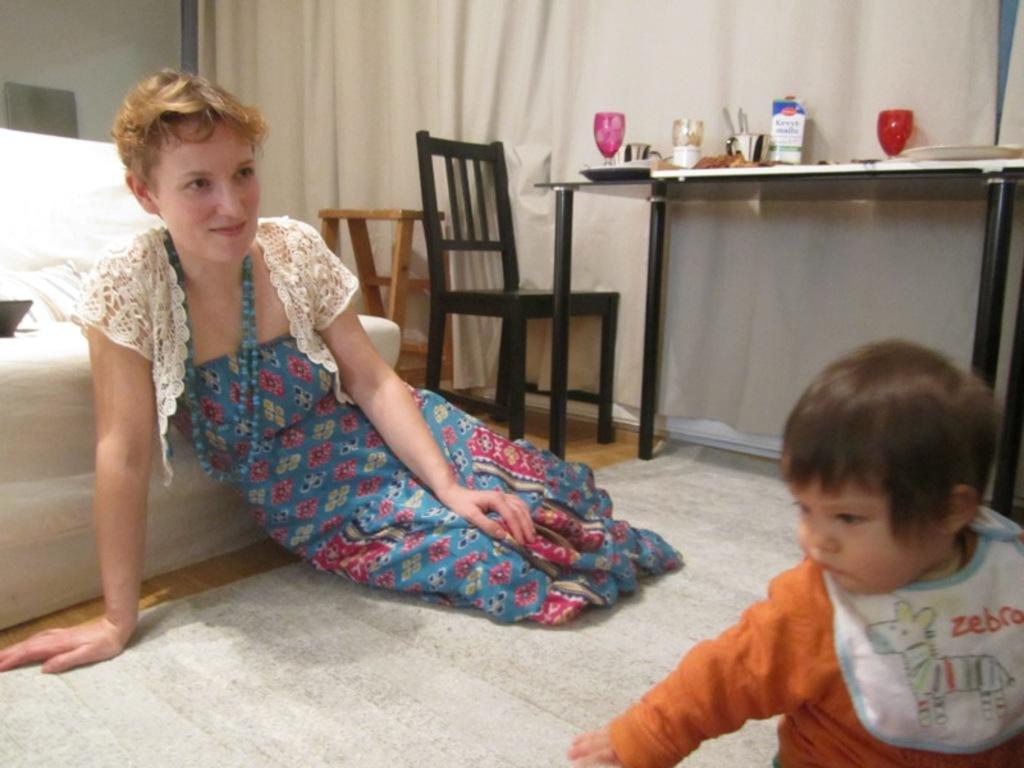<image>
Describe the image concisely. the word zebra is on the bib of the baby 